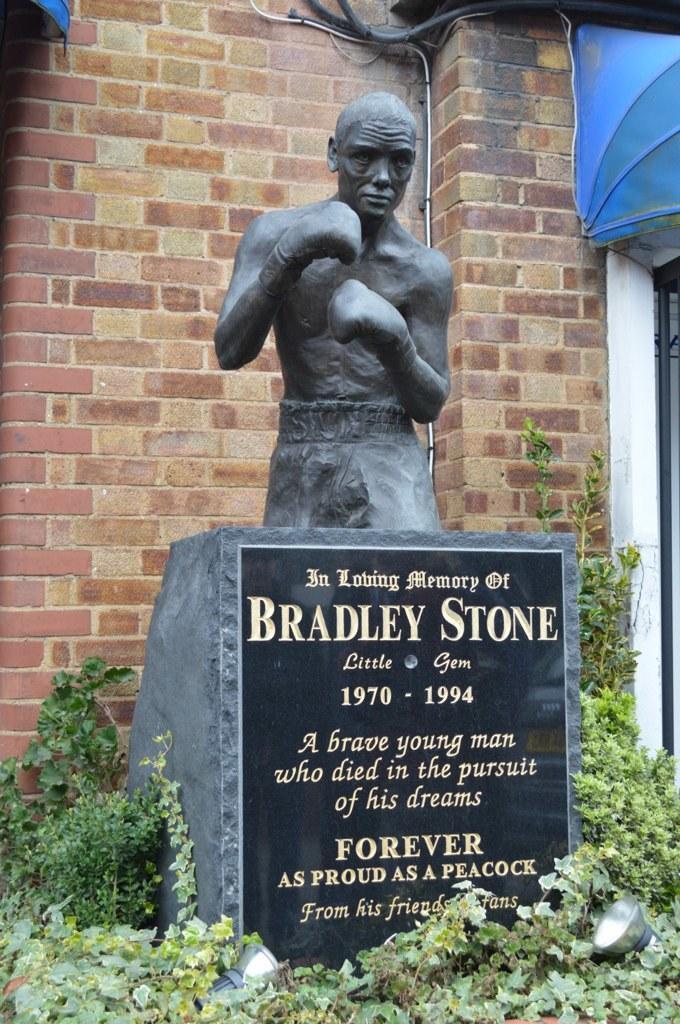How would you summarize this image in a sentence or two? In the picture we can see a man sculpture on the stone and around the stone we can see the plants and behind the stone we can see the wall. 